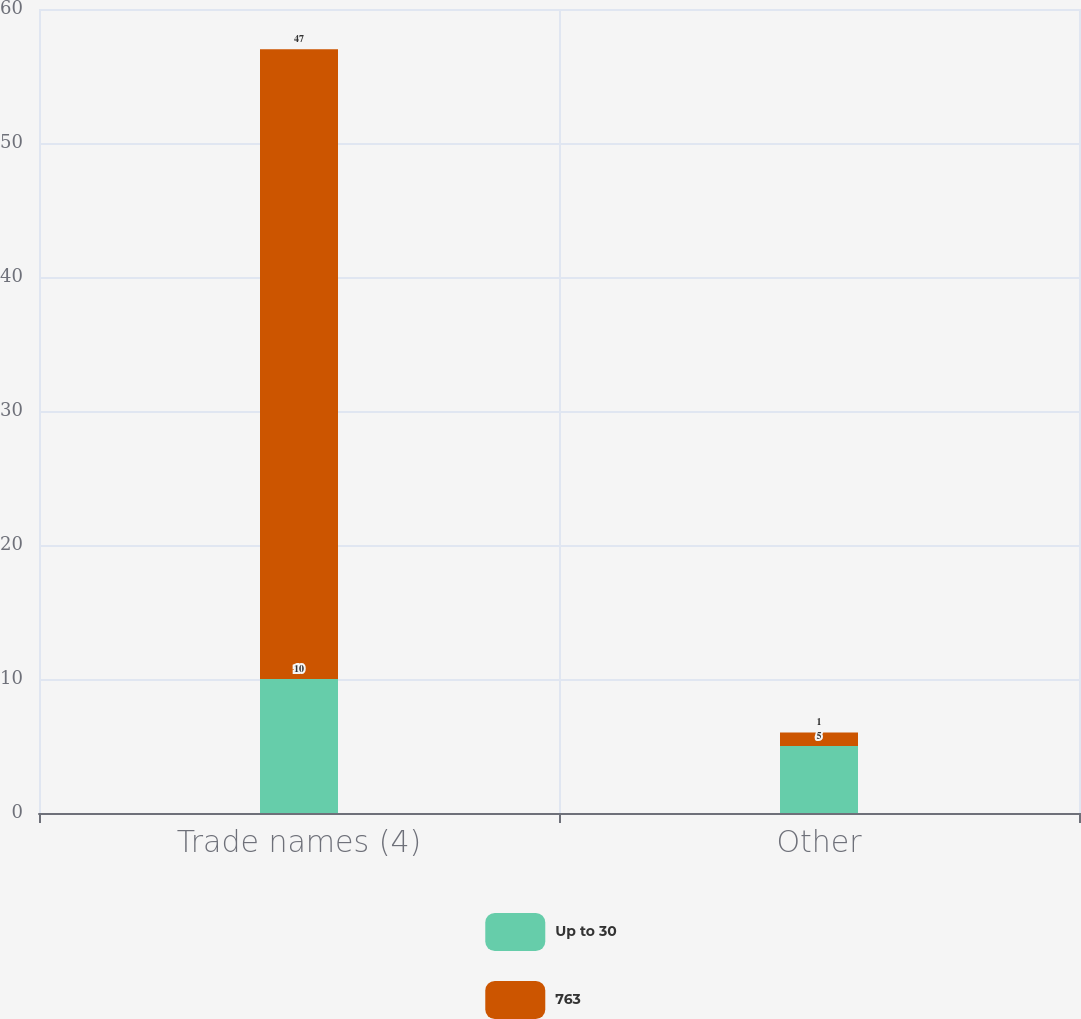<chart> <loc_0><loc_0><loc_500><loc_500><stacked_bar_chart><ecel><fcel>Trade names (4)<fcel>Other<nl><fcel>Up to 30<fcel>10<fcel>5<nl><fcel>763<fcel>47<fcel>1<nl></chart> 